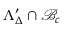<formula> <loc_0><loc_0><loc_500><loc_500>\Lambda _ { \Delta } ^ { \prime } \cap \mathcal { B } _ { c }</formula> 